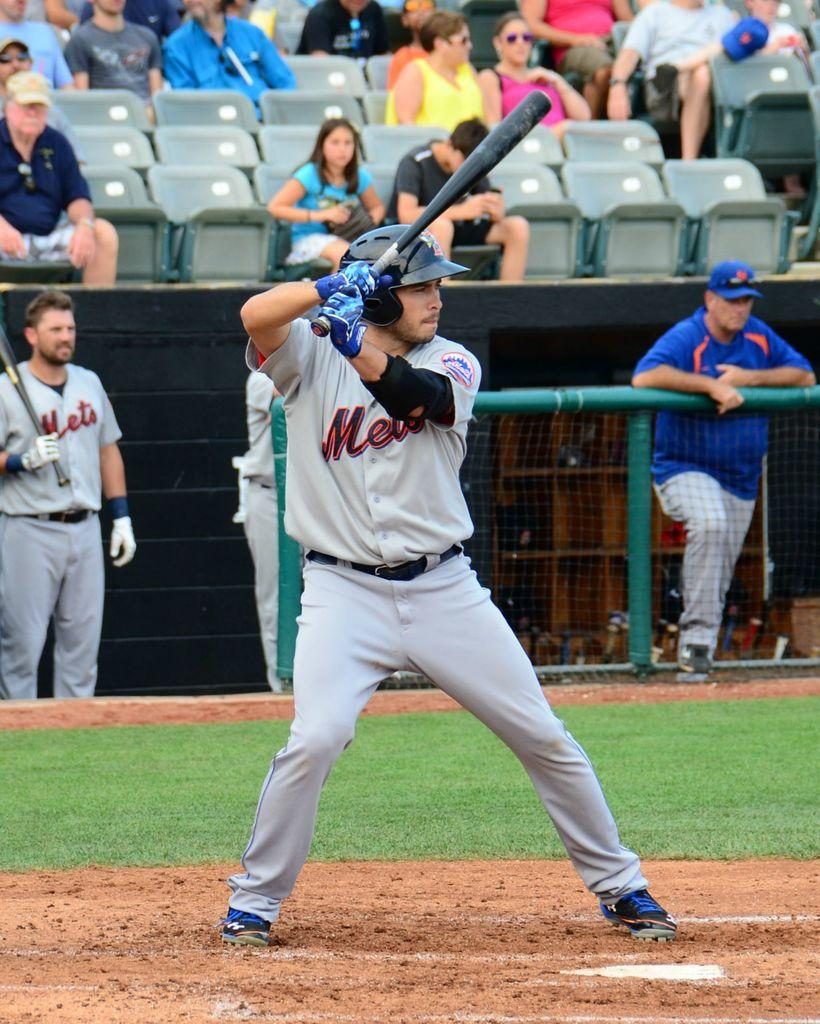Who is the main subject in the image? There is a man in the image. What is the man wearing? The man is wearing a white dress. What activity is the man engaged in? The man is playing baseball. What can be seen in the background of the image? There are people sitting in chairs in the background of the image. What type of surface is visible at the bottom of the image? There is ground visible at the bottom of the image. What is the price of the woman's dress in the image? There is no woman present in the image, only a man wearing a white dress. What type of operation is being performed on the man in the image? There is no operation being performed on the man in the image; he is playing baseball. 